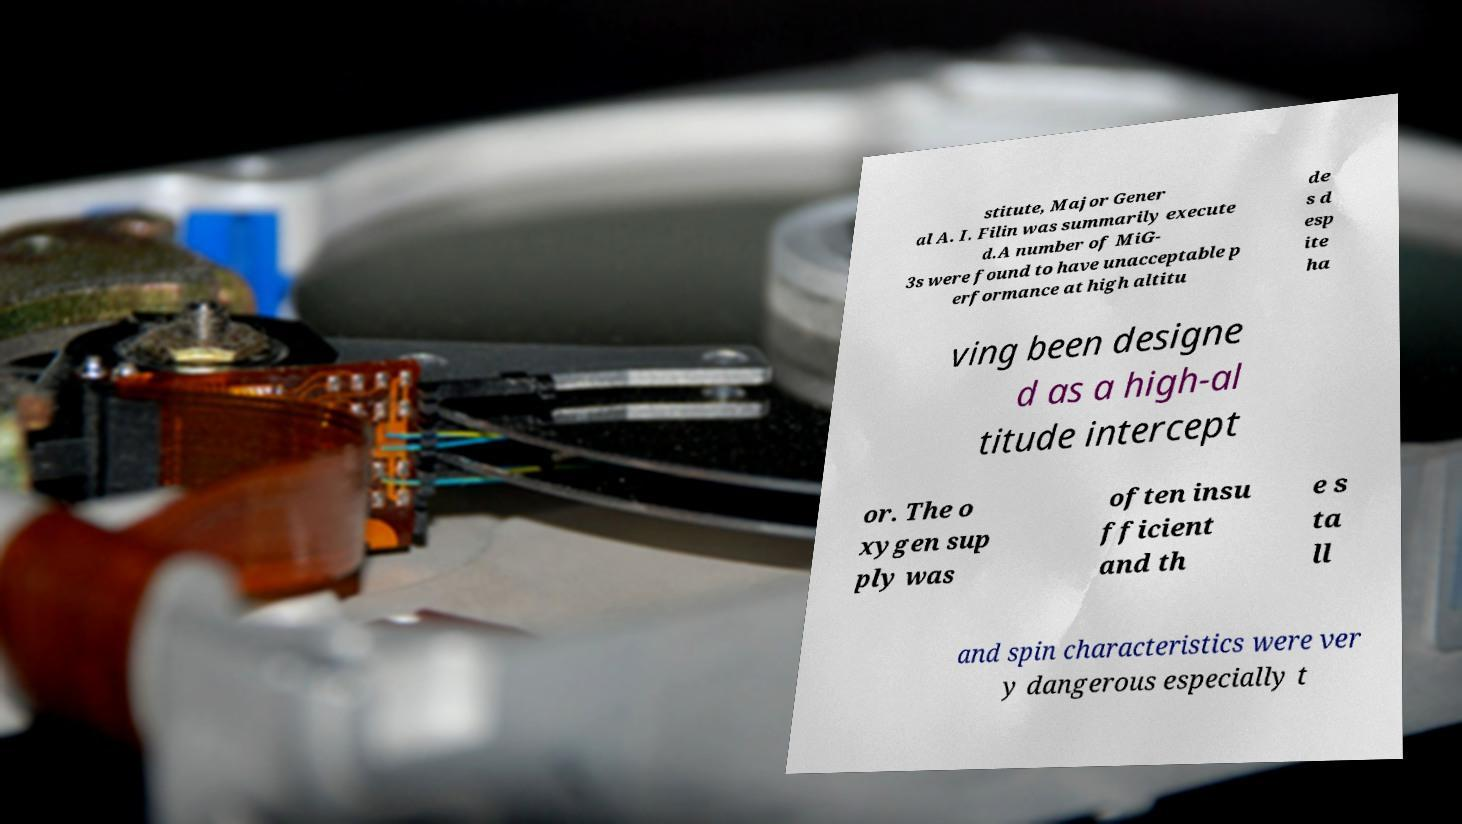I need the written content from this picture converted into text. Can you do that? stitute, Major Gener al A. I. Filin was summarily execute d.A number of MiG- 3s were found to have unacceptable p erformance at high altitu de s d esp ite ha ving been designe d as a high-al titude intercept or. The o xygen sup ply was often insu fficient and th e s ta ll and spin characteristics were ver y dangerous especially t 